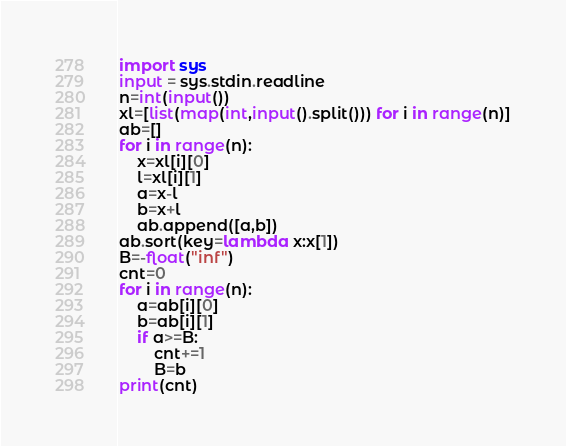Convert code to text. <code><loc_0><loc_0><loc_500><loc_500><_Python_>import sys
input = sys.stdin.readline
n=int(input())
xl=[list(map(int,input().split())) for i in range(n)]
ab=[]
for i in range(n):
    x=xl[i][0]
    l=xl[i][1]
    a=x-l
    b=x+l
    ab.append([a,b])
ab.sort(key=lambda x:x[1])
B=-float("inf")
cnt=0
for i in range(n):
    a=ab[i][0]
    b=ab[i][1]
    if a>=B:
        cnt+=1
        B=b
print(cnt)
</code> 